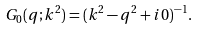Convert formula to latex. <formula><loc_0><loc_0><loc_500><loc_500>G _ { 0 } ( q ; k ^ { 2 } ) = ( k ^ { 2 } - q ^ { 2 } + i 0 ) ^ { - 1 } .</formula> 